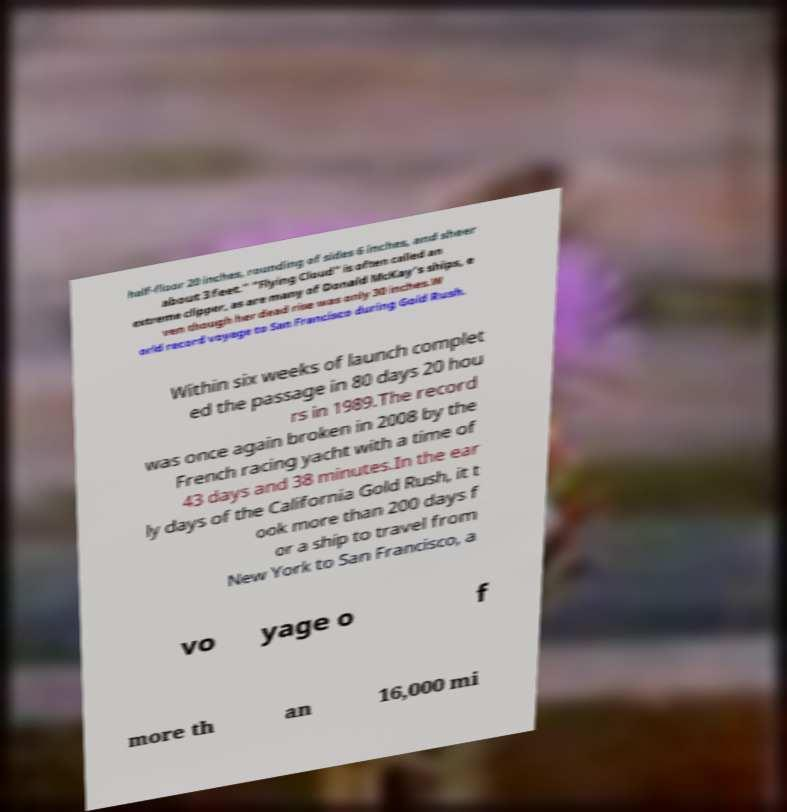Please identify and transcribe the text found in this image. half-floor 20 inches, rounding of sides 6 inches, and sheer about 3 feet." "Flying Cloud" is often called an extreme clipper, as are many of Donald McKay's ships, e ven though her dead rise was only 30 inches.W orld record voyage to San Francisco during Gold Rush. Within six weeks of launch complet ed the passage in 80 days 20 hou rs in 1989.The record was once again broken in 2008 by the French racing yacht with a time of 43 days and 38 minutes.In the ear ly days of the California Gold Rush, it t ook more than 200 days f or a ship to travel from New York to San Francisco, a vo yage o f more th an 16,000 mi 